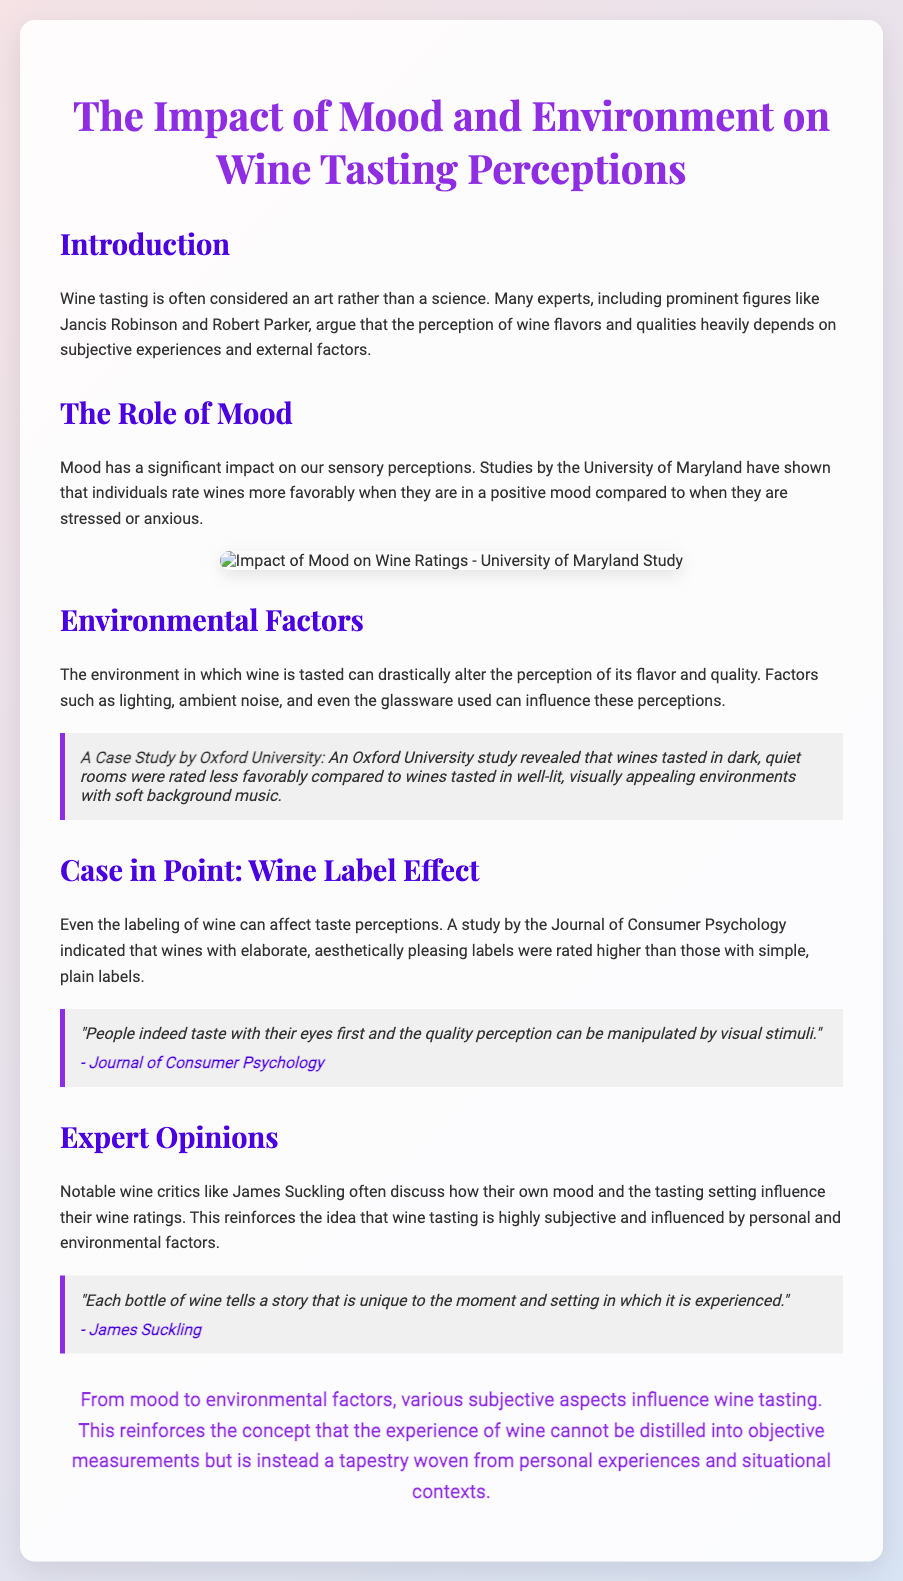What is the title of the presentation? The title is presented at the top of the slide as the main topic of discussion.
Answer: The Impact of Mood and Environment on Wine Tasting Perceptions Who conducted the studies mentioned about the impact of mood on wine ratings? The University of Maryland is referenced for their studies on mood and wine tasting.
Answer: University of Maryland What does the Oxford University study compare? The study compares the ratings of wines in different environmental conditions such as dark vs. well-lit rooms.
Answer: Dark, quiet rooms vs. well-lit, visually appealing environments Which journal discussed the influence of wine labeling on perceptions? The Journal of Consumer Psychology is cited for its findings on wine label effects.
Answer: Journal of Consumer Psychology According to James Suckling, what does each bottle of wine tell? James Suckling's quote emphasizes the uniqueness of each wine's experience related to the moment.
Answer: A story that is unique to the moment and setting What is the overall conclusion stated in the presentation? The conclusion summarizes the influence of subjective aspects on wine tasting experience as opposed to objective measurements.
Answer: The experience of wine cannot be distilled into objective measurements How does mood affect wine ratings according to the document? The document states that individuals rate wines more favorably when they are in a positive mood.
Answer: More favorably in a positive mood What impact does environmental noise have according to the study? The study implies that ambient noise alters the perception of the wine quality during tasting sessions.
Answer: Alters the perception of its flavor and quality 